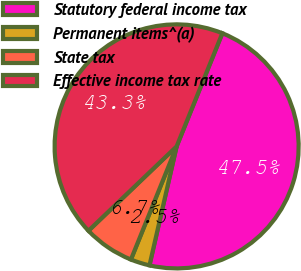<chart> <loc_0><loc_0><loc_500><loc_500><pie_chart><fcel>Statutory federal income tax<fcel>Permanent items^(a)<fcel>State tax<fcel>Effective income tax rate<nl><fcel>47.46%<fcel>2.54%<fcel>6.74%<fcel>43.26%<nl></chart> 